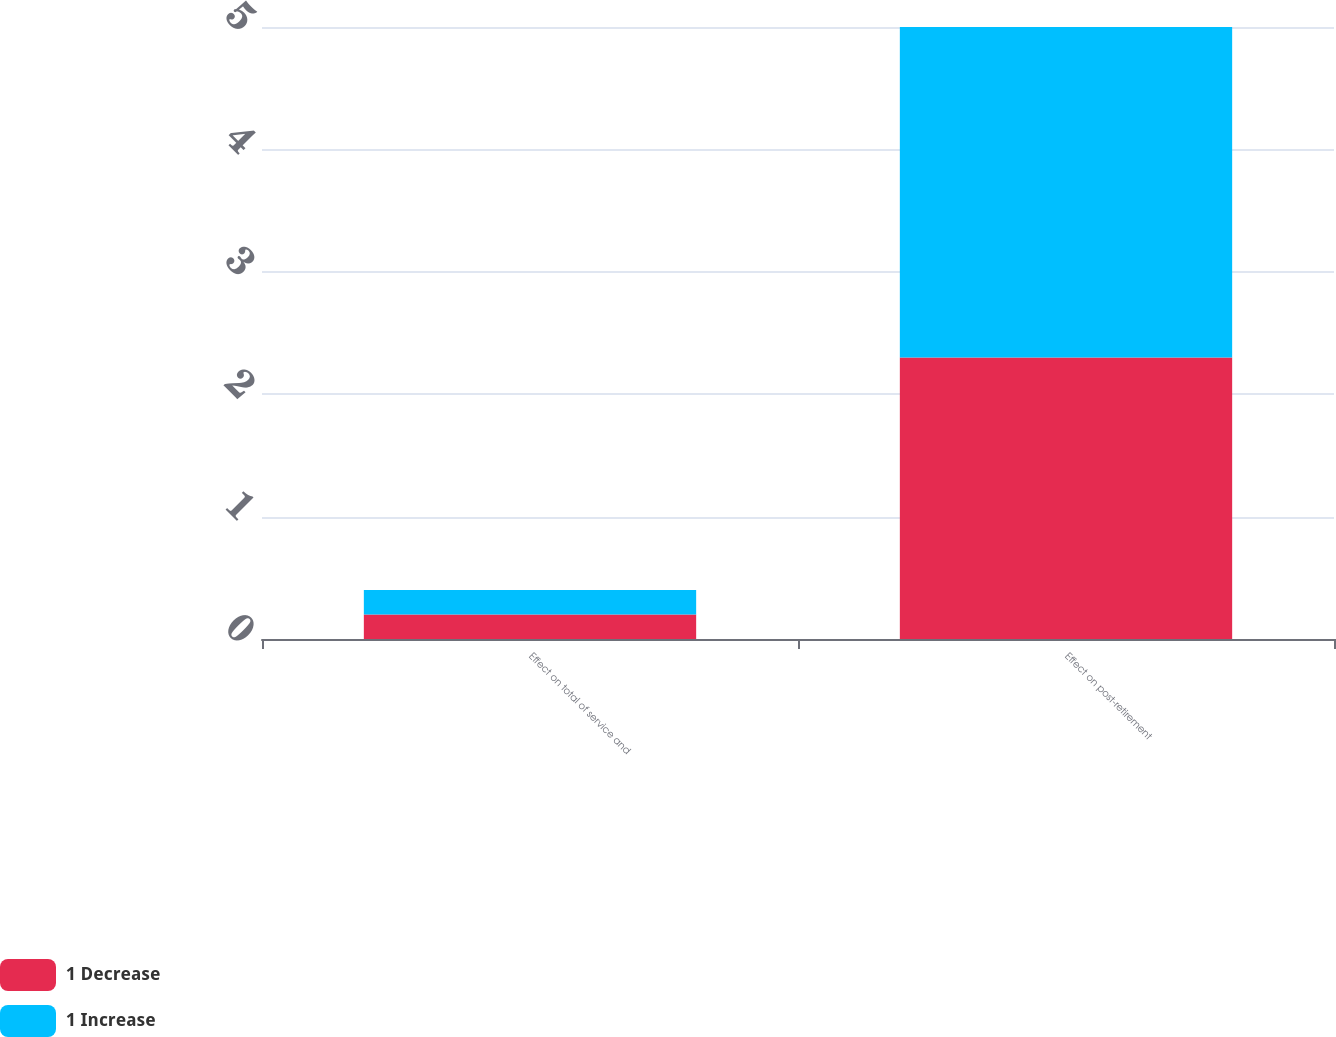<chart> <loc_0><loc_0><loc_500><loc_500><stacked_bar_chart><ecel><fcel>Effect on total of service and<fcel>Effect on post-retirement<nl><fcel>1 Decrease<fcel>0.2<fcel>2.3<nl><fcel>1 Increase<fcel>0.2<fcel>2.7<nl></chart> 